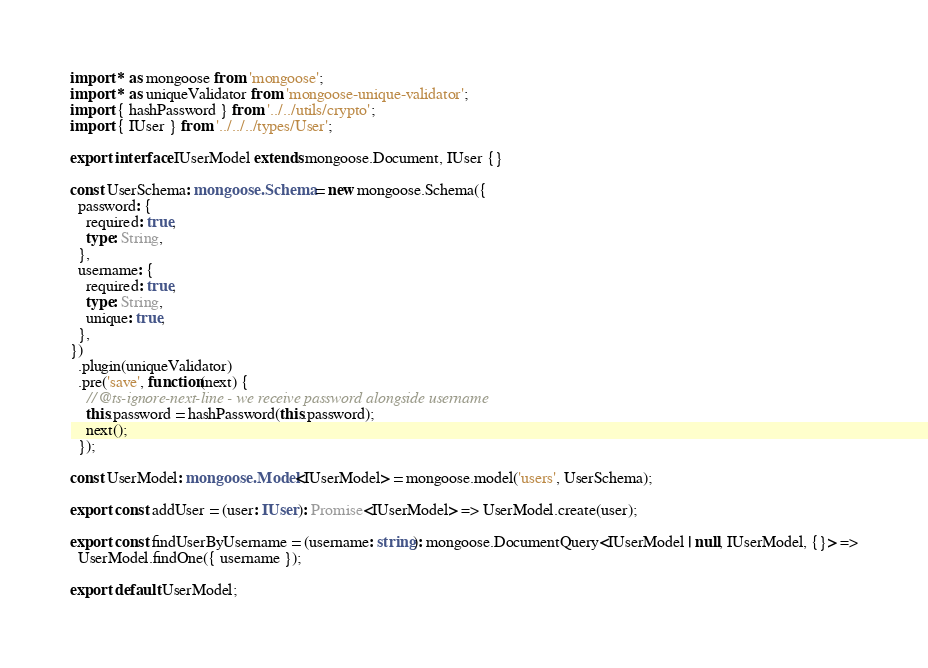Convert code to text. <code><loc_0><loc_0><loc_500><loc_500><_TypeScript_>import * as mongoose from 'mongoose';
import * as uniqueValidator from 'mongoose-unique-validator';
import { hashPassword } from '../../utils/crypto';
import { IUser } from '../../../types/User';

export interface IUserModel extends mongoose.Document, IUser {}

const UserSchema: mongoose.Schema = new mongoose.Schema({
  password: {
    required: true,
    type: String,
  },
  username: {
    required: true,
    type: String,
    unique: true,
  },
})
  .plugin(uniqueValidator)
  .pre('save', function(next) {
    // @ts-ignore-next-line - we receive password alongside username
    this.password = hashPassword(this.password);
    next();
  });

const UserModel: mongoose.Model<IUserModel> = mongoose.model('users', UserSchema);

export const addUser = (user: IUser): Promise<IUserModel> => UserModel.create(user);

export const findUserByUsername = (username: string): mongoose.DocumentQuery<IUserModel | null, IUserModel, {}> =>
  UserModel.findOne({ username });

export default UserModel;
</code> 